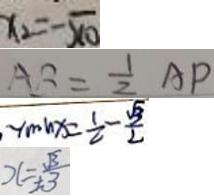Convert formula to latex. <formula><loc_0><loc_0><loc_500><loc_500>x _ { 2 } = - \sqrt { 1 0 } 
 A B = \frac { 1 } { 2 } A P 
 \min x = \frac { 1 } { 2 } - \frac { \sqrt { 3 } } { 2 } 
 x = \pm \frac { \sqrt { 3 } } { 3 }</formula> 